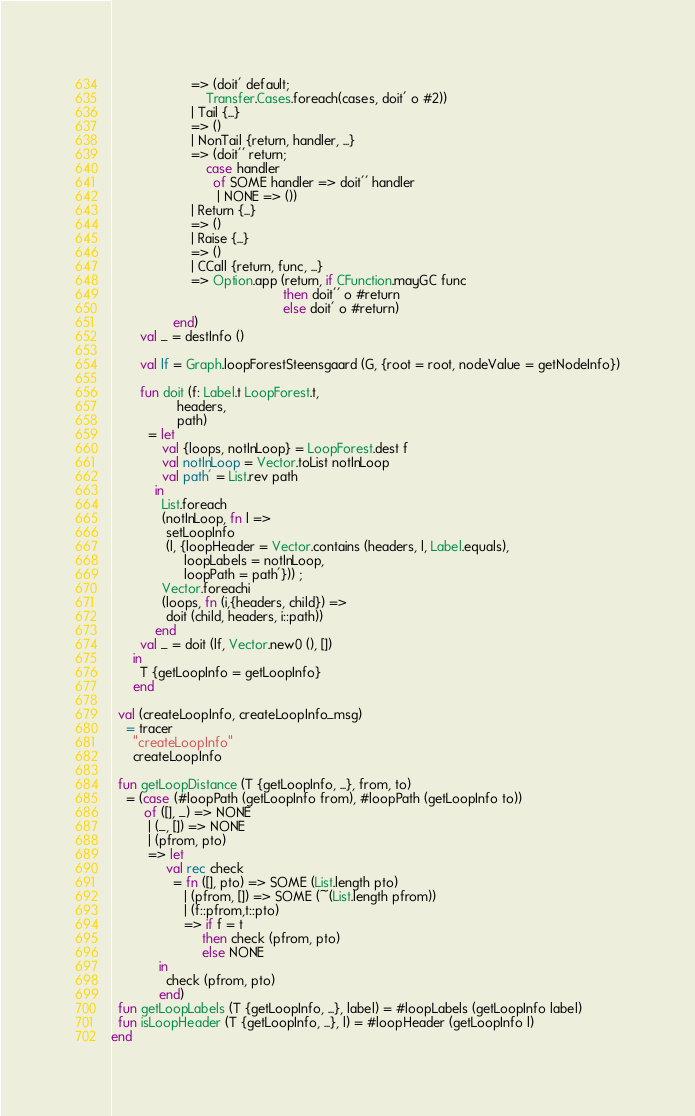<code> <loc_0><loc_0><loc_500><loc_500><_SML_>                      => (doit' default;
                          Transfer.Cases.foreach(cases, doit' o #2))
                      | Tail {...}
                      => ()
                      | NonTail {return, handler, ...}
                      => (doit'' return;
                          case handler 
                            of SOME handler => doit'' handler
                             | NONE => ())
                      | Return {...}
                      => ()
                      | Raise {...}
                      => ()
                      | CCall {return, func, ...}
                      => Option.app (return, if CFunction.mayGC func
                                               then doit'' o #return
                                               else doit' o #return)
                 end)
        val _ = destInfo ()

        val lf = Graph.loopForestSteensgaard (G, {root = root, nodeValue = getNodeInfo})

        fun doit (f: Label.t LoopForest.t,
                  headers,
                  path)
          = let
              val {loops, notInLoop} = LoopForest.dest f
              val notInLoop = Vector.toList notInLoop
              val path' = List.rev path
            in
              List.foreach
              (notInLoop, fn l =>
               setLoopInfo 
               (l, {loopHeader = Vector.contains (headers, l, Label.equals),
                    loopLabels = notInLoop,
                    loopPath = path'})) ;
              Vector.foreachi
              (loops, fn (i,{headers, child}) =>
               doit (child, headers, i::path))
            end
        val _ = doit (lf, Vector.new0 (), [])
      in
        T {getLoopInfo = getLoopInfo}
      end

  val (createLoopInfo, createLoopInfo_msg)
    = tracer
      "createLoopInfo"
      createLoopInfo

  fun getLoopDistance (T {getLoopInfo, ...}, from, to)
    = (case (#loopPath (getLoopInfo from), #loopPath (getLoopInfo to))
         of ([], _) => NONE
          | (_, []) => NONE
          | (pfrom, pto)
          => let
               val rec check
                 = fn ([], pto) => SOME (List.length pto)
                    | (pfrom, []) => SOME (~(List.length pfrom))
                    | (f::pfrom,t::pto)
                    => if f = t
                         then check (pfrom, pto)
                         else NONE
             in
               check (pfrom, pto)
             end)
  fun getLoopLabels (T {getLoopInfo, ...}, label) = #loopLabels (getLoopInfo label)
  fun isLoopHeader (T {getLoopInfo, ...}, l) = #loopHeader (getLoopInfo l)
end
</code> 